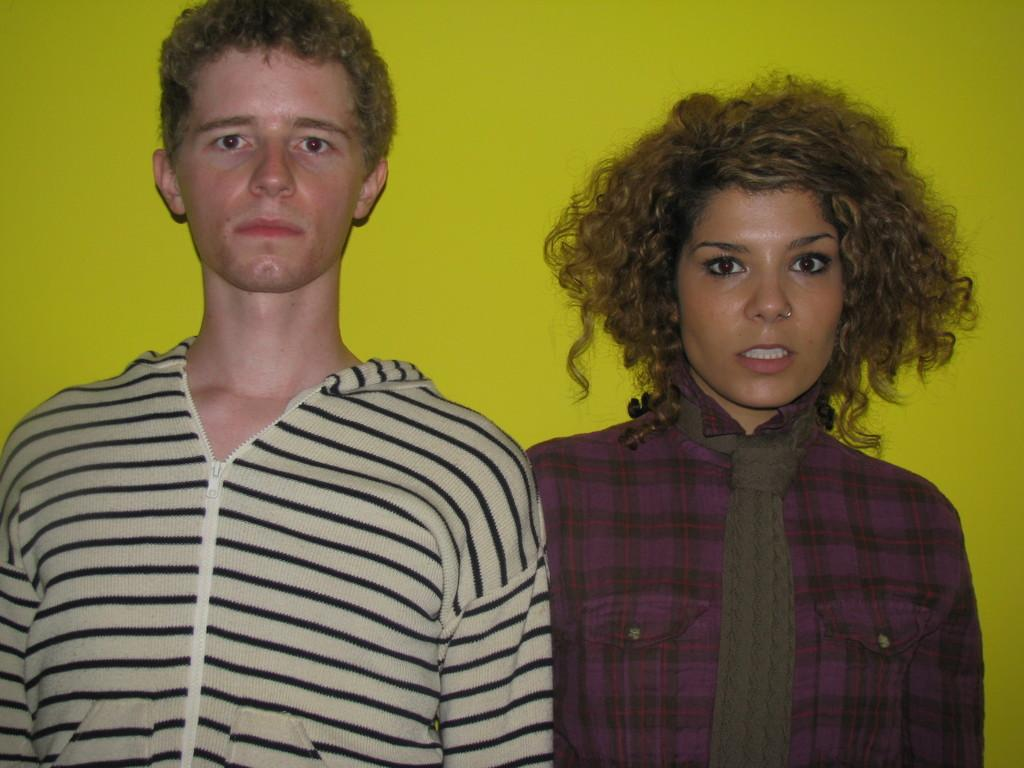How many people are present in the image? There are two people, a man and a woman, present in the image. What is the woman wearing in the image? The woman is wearing a scarf in the image. What can be seen in the background of the image? There is a wall in the background of the image. What type of magic is the woman performing in the image? There is no indication of magic or any magical activity in the image. 